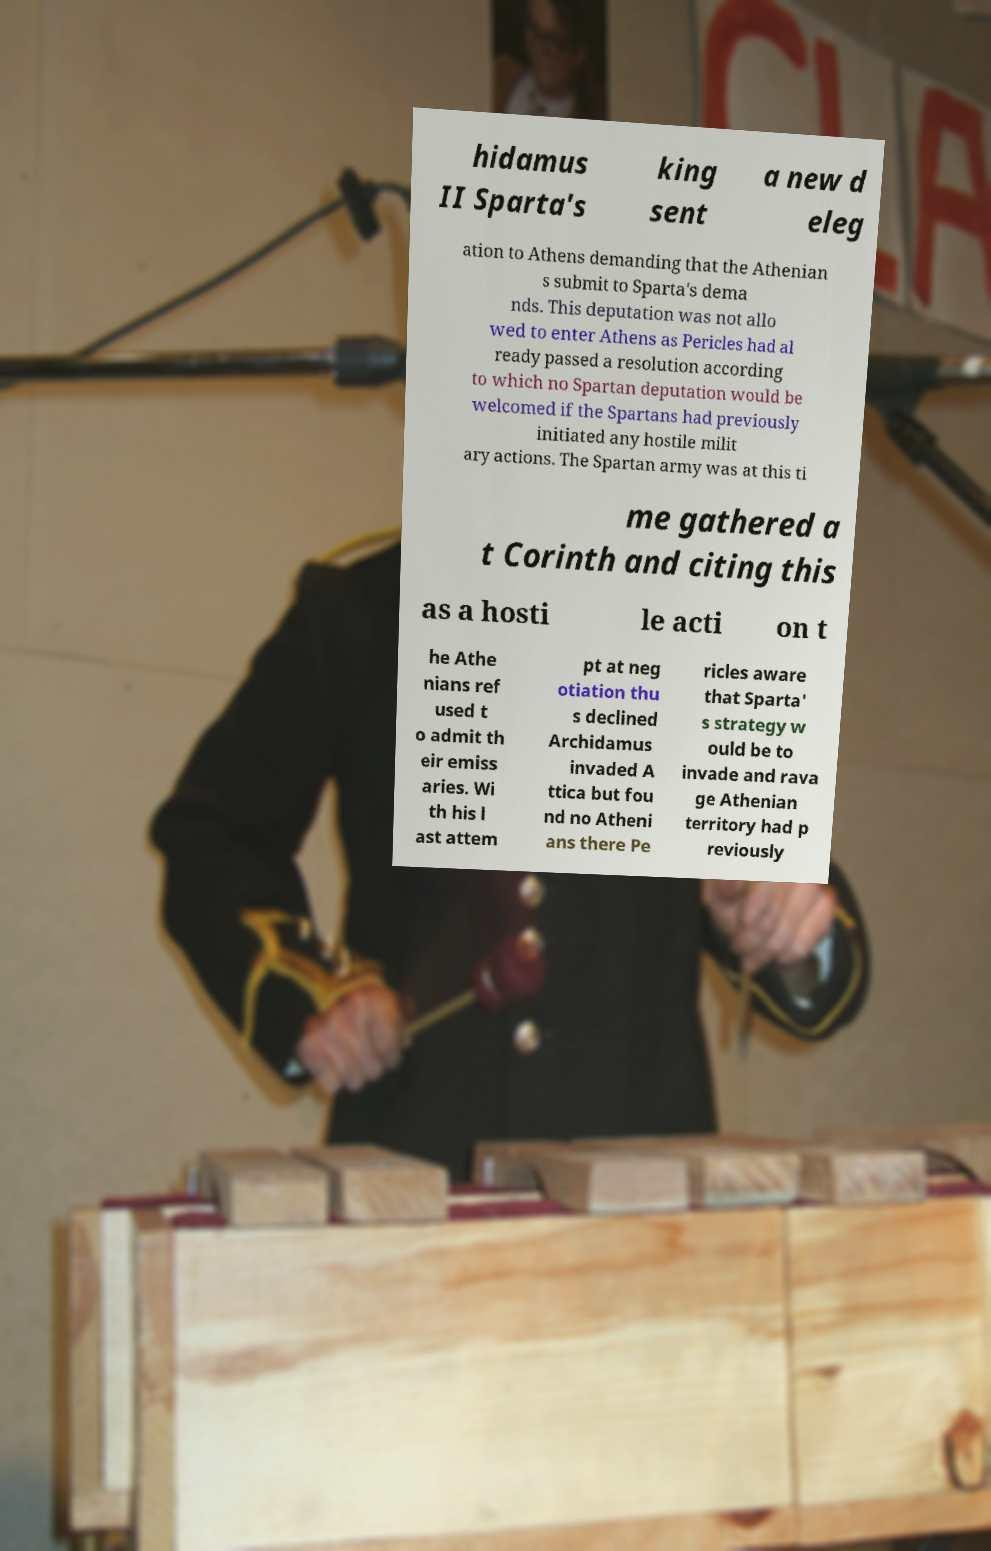There's text embedded in this image that I need extracted. Can you transcribe it verbatim? hidamus II Sparta's king sent a new d eleg ation to Athens demanding that the Athenian s submit to Sparta's dema nds. This deputation was not allo wed to enter Athens as Pericles had al ready passed a resolution according to which no Spartan deputation would be welcomed if the Spartans had previously initiated any hostile milit ary actions. The Spartan army was at this ti me gathered a t Corinth and citing this as a hosti le acti on t he Athe nians ref used t o admit th eir emiss aries. Wi th his l ast attem pt at neg otiation thu s declined Archidamus invaded A ttica but fou nd no Atheni ans there Pe ricles aware that Sparta' s strategy w ould be to invade and rava ge Athenian territory had p reviously 